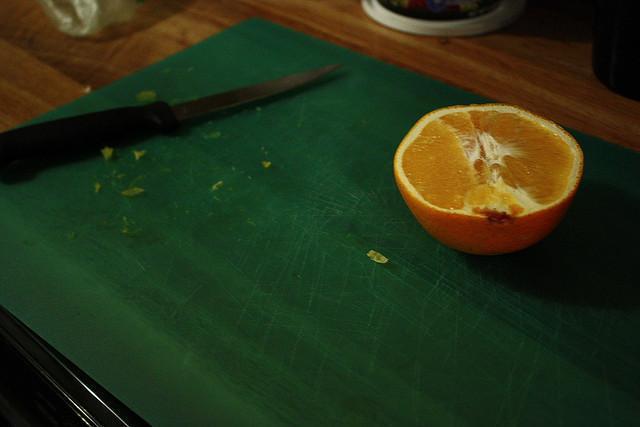How many slices of orange are there?
Give a very brief answer. 1. How many seeds are there?
Give a very brief answer. 0. How many people are wearing a pink shirt?
Give a very brief answer. 0. 